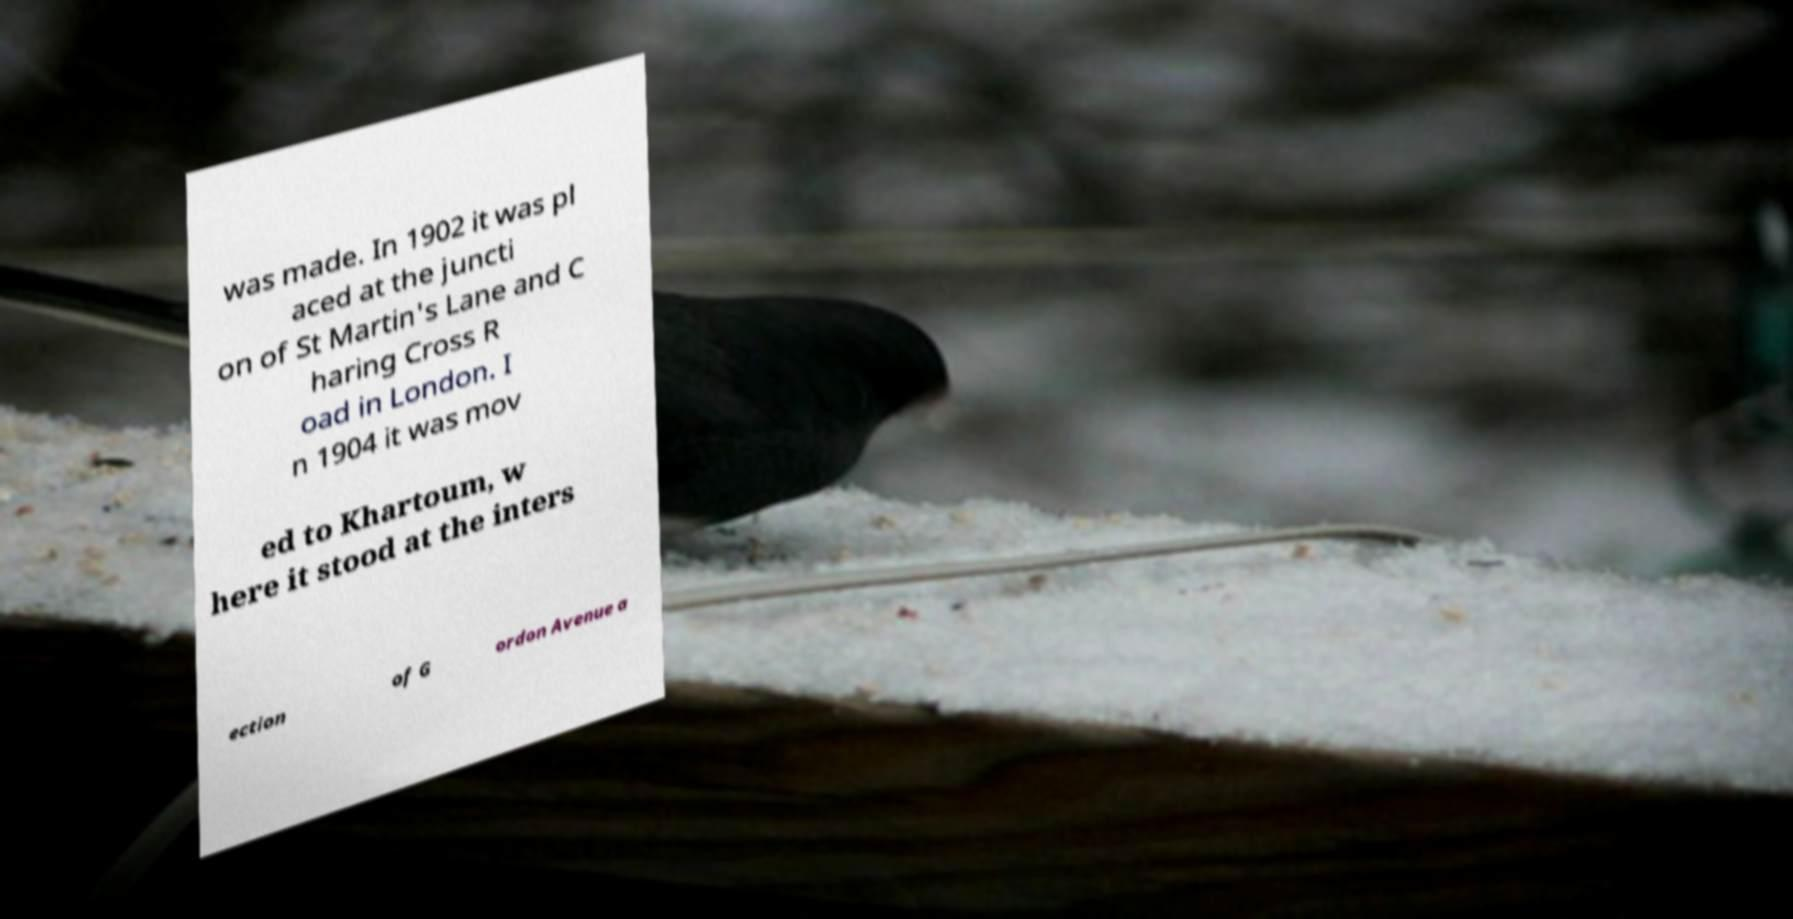What messages or text are displayed in this image? I need them in a readable, typed format. was made. In 1902 it was pl aced at the juncti on of St Martin's Lane and C haring Cross R oad in London. I n 1904 it was mov ed to Khartoum, w here it stood at the inters ection of G ordon Avenue a 